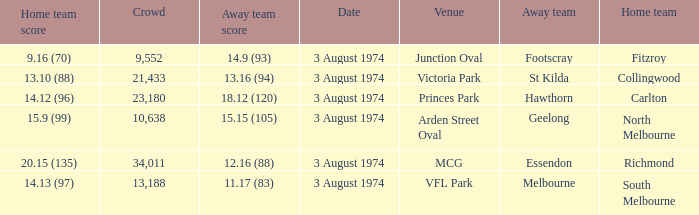Which Venue has a Home team score of 9.16 (70)? Junction Oval. 